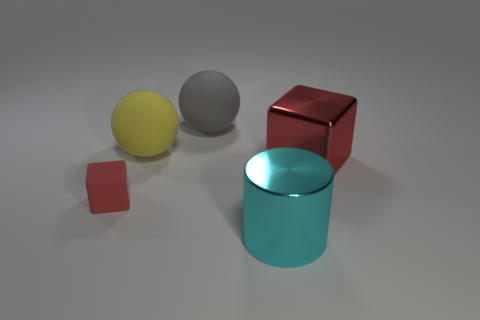Add 3 brown blocks. How many objects exist? 8 Subtract all cylinders. How many objects are left? 4 Add 1 big red shiny cubes. How many big red shiny cubes are left? 2 Add 2 large brown rubber spheres. How many large brown rubber spheres exist? 2 Subtract 0 green spheres. How many objects are left? 5 Subtract all metal blocks. Subtract all big blue rubber balls. How many objects are left? 4 